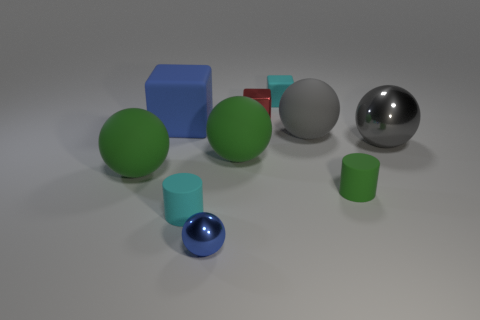Subtract all blue spheres. How many spheres are left? 4 Subtract 1 blocks. How many blocks are left? 2 Subtract all tiny blue spheres. How many spheres are left? 4 Subtract all blue spheres. Subtract all yellow cylinders. How many spheres are left? 4 Subtract all cubes. How many objects are left? 7 Add 5 green cylinders. How many green cylinders exist? 6 Subtract 0 yellow cylinders. How many objects are left? 10 Subtract all small red shiny cubes. Subtract all green cylinders. How many objects are left? 8 Add 6 tiny cyan rubber cylinders. How many tiny cyan rubber cylinders are left? 7 